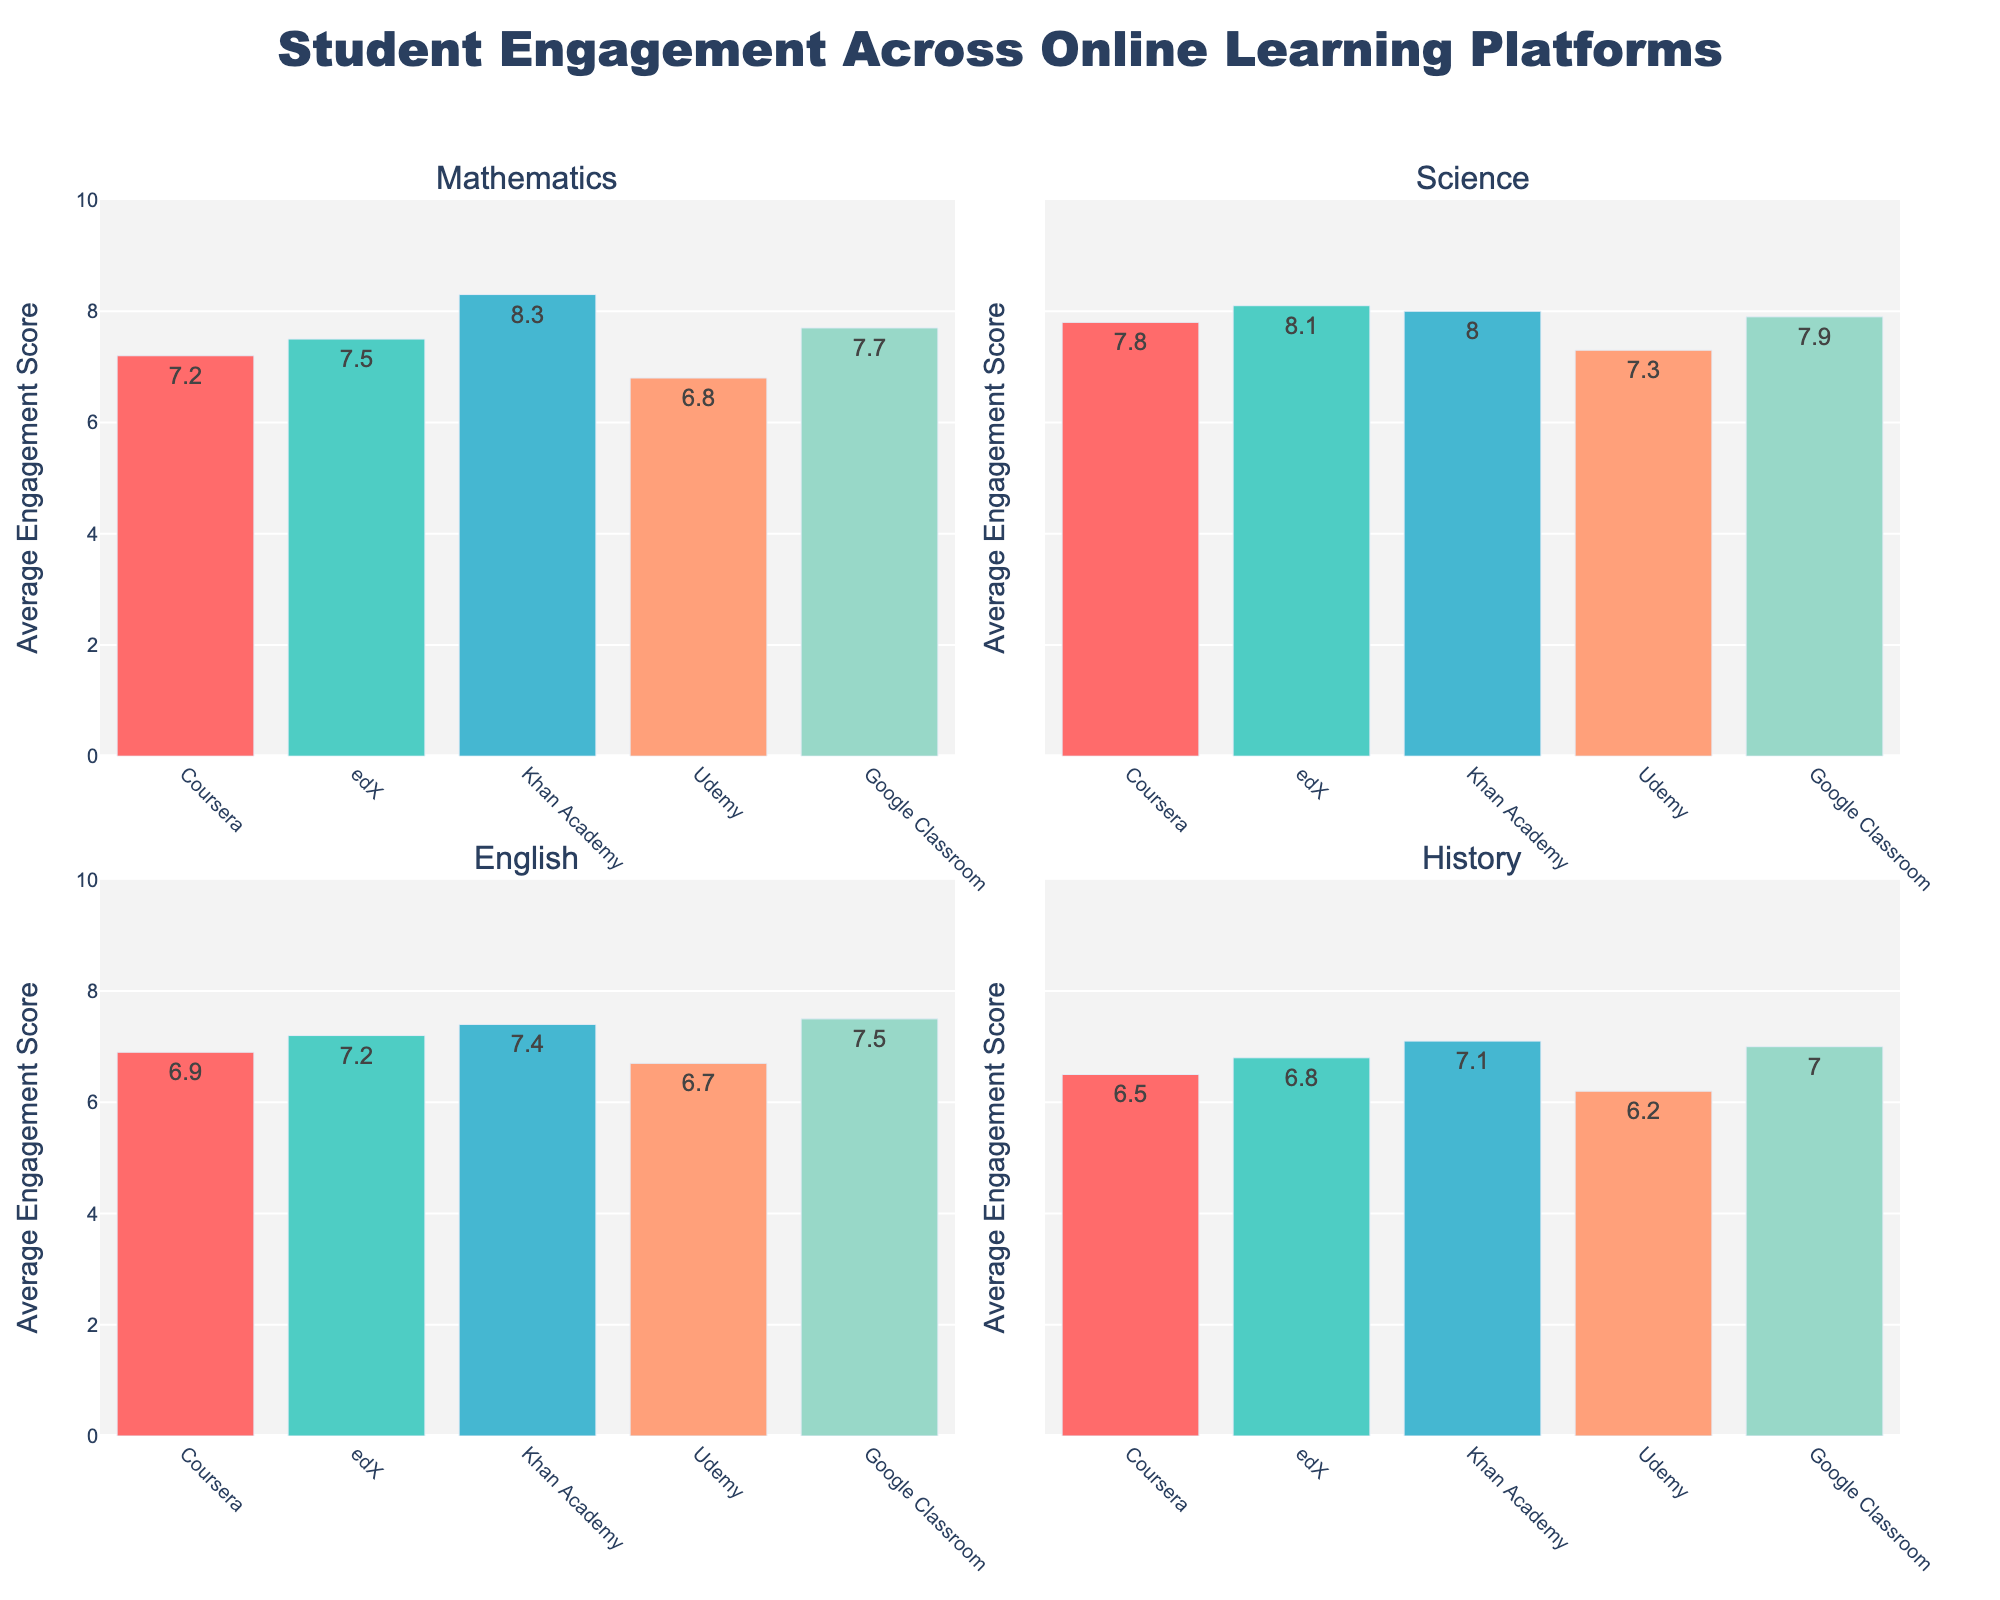Which subject has the highest average engagement score across all platforms? The highest average engagement score in the Science subplot is associated with edX, scoring 8.1.
Answer: Science What is the average engagement score for Google Classroom in the English subject? From the plot for English, Google Classroom has an average engagement score of 7.5.
Answer: 7.5 Which platform has the lowest average engagement score in the Mathematics subject? Udemy has the lowest average engagement score in Mathematics, which is 6.8 as shown in the Mathematics subplot.
Answer: Udemy Between Coursera and Khan Academy, which platform has a higher engagement score for History? Comparing the History subplot, Khan Academy has a higher engagement score (7.1) than Coursera (6.5).
Answer: Khan Academy Which platform shows consistent engagement scores above 7 across all subjects? Google Classroom has consistent engagement scores above 7 across all subjects as observed in all subplots: Mathematics (7.7), Science (7.9), English (7.5), and History (7.0).
Answer: Google Classroom What is the difference in the average engagement scores between edX and Coursera for Science? From the Science subplot, the average engagement score for edX is 8.1 and for Coursera is 7.8. The difference is 8.1 - 7.8 = 0.3
Answer: 0.3 Is the engagement score for Khan Academy higher than Udemy for all subjects? Based on the subplots: Khan Academy consistently shows higher scores than Udemy in all subjects - Mathematics (8.3 vs 6.8), Science (8.0 vs 7.3), English (7.4 vs 6.7), and History (7.1 vs 6.2).
Answer: Yes How many platforms have an engagement score of 7.0 or above in History? In the History subplot, the platforms with scores 7.0 or above are Khan Academy (7.1), Google Classroom (7.0), and edX (6.8 does not qualify), resulting in 3 platforms.
Answer: 3 What is the range of the engagement scores in the Mathematics subject? In the Mathematics subplot, the highest score is from Khan Academy (8.3) and the lowest is from Udemy (6.8), giving a range of 8.3 - 6.8 = 1.5
Answer: 1.5 